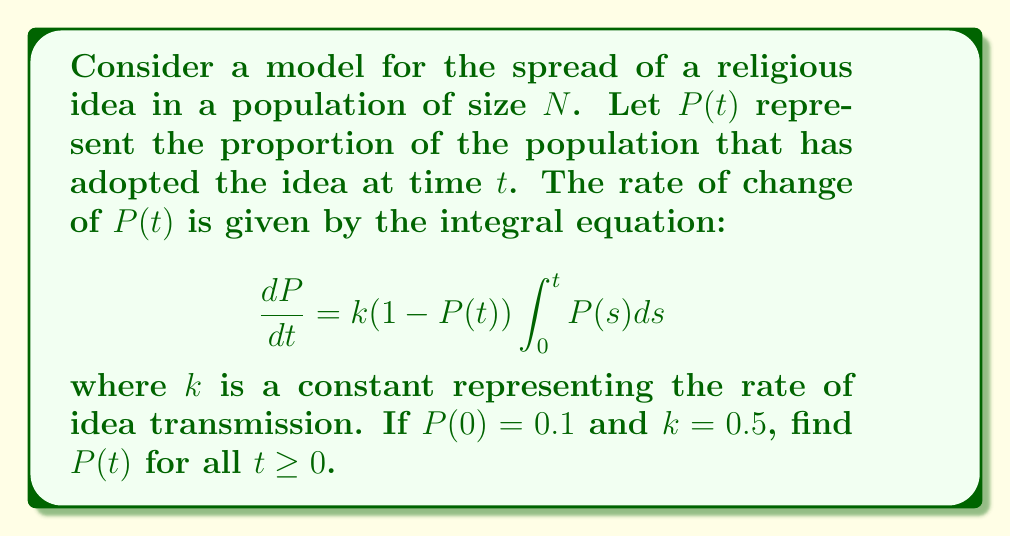Can you solve this math problem? To solve this integral equation, we'll follow these steps:

1) First, let's define $Q(t) = \int_0^t P(s)ds$. This means that $\frac{dQ}{dt} = P(t)$.

2) Now, we can rewrite our original equation in terms of Q:

   $$\frac{dP}{dt} = k(1-P)Q$$

3) We also know that $\frac{dQ}{dt} = P$. Let's differentiate this:

   $$\frac{d^2Q}{dt^2} = \frac{dP}{dt} = k(1-P)Q = k(1-\frac{dQ}{dt})Q$$

4) This is a nonlinear second-order differential equation. To solve it, let's make the substitution $y = \frac{dQ}{dt}$. Then $\frac{d^2Q}{dt^2} = \frac{dy}{dt}$.

5) Our equation becomes:

   $$\frac{dy}{dt} = k(1-y)Q$$

6) Now, let's separate variables:

   $$\frac{dy}{(1-y)Q} = kdt$$

7) Integrating both sides:

   $$-\ln(1-y) = \frac{kQ^2}{2} + C$$

8) Solving for y:

   $$y = 1 - Ae^{-\frac{kQ^2}{2}}$$

   where A is a constant of integration.

9) Remember that $y = \frac{dQ}{dt} = P$, so:

   $$P(t) = 1 - Ae^{-\frac{kQ^2}{2}}$$

10) To find A, we use the initial condition $P(0) = 0.1$:

    $$0.1 = 1 - A$$
    $$A = 0.9$$

11) Therefore, our final solution is:

    $$P(t) = 1 - 0.9e^{-\frac{k}{2}(\int_0^t P(s)ds)^2}$$

12) With $k = 0.5$, our solution becomes:

    $$P(t) = 1 - 0.9e^{-\frac{1}{4}(\int_0^t P(s)ds)^2}$$

This is an implicit solution for $P(t)$, as $P(t)$ appears on both sides of the equation.
Answer: $P(t) = 1 - 0.9e^{-\frac{1}{4}(\int_0^t P(s)ds)^2}$ 